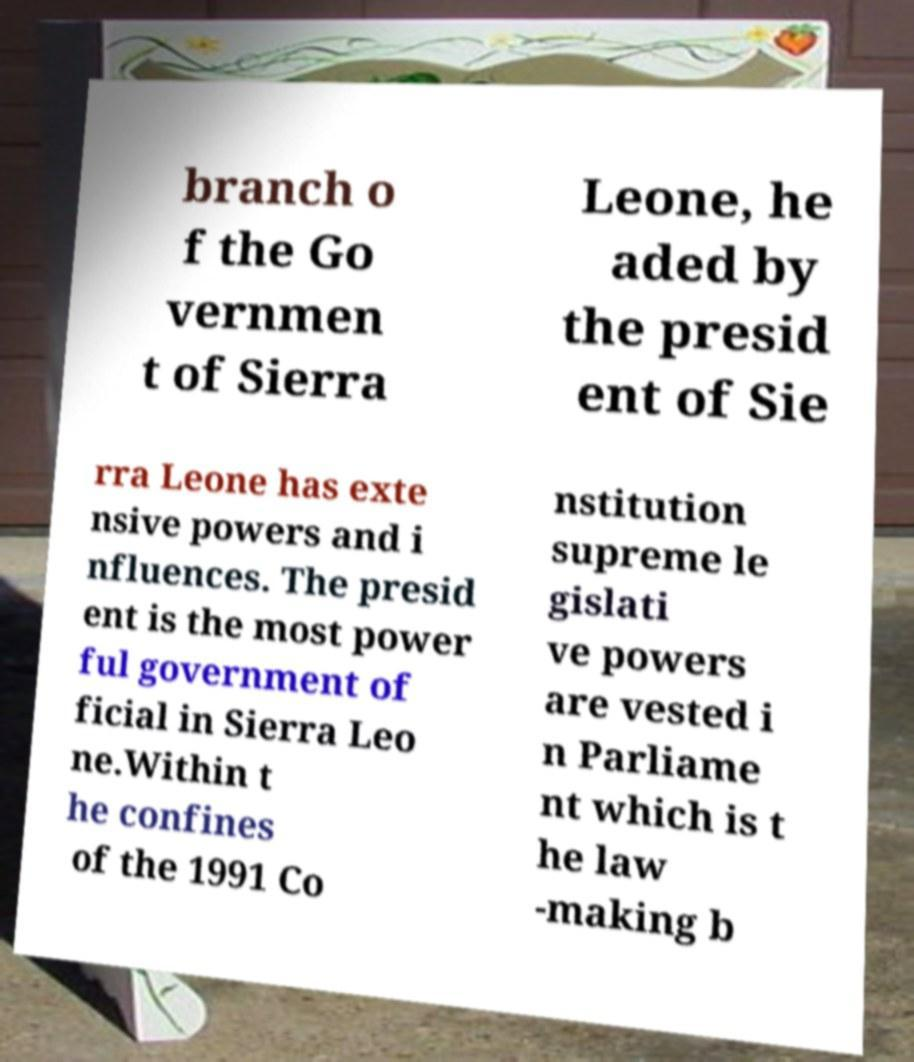Please identify and transcribe the text found in this image. branch o f the Go vernmen t of Sierra Leone, he aded by the presid ent of Sie rra Leone has exte nsive powers and i nfluences. The presid ent is the most power ful government of ficial in Sierra Leo ne.Within t he confines of the 1991 Co nstitution supreme le gislati ve powers are vested i n Parliame nt which is t he law -making b 